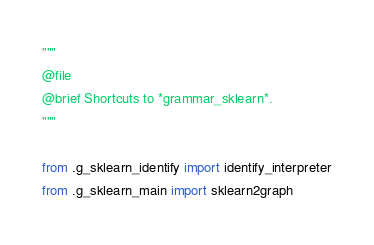<code> <loc_0><loc_0><loc_500><loc_500><_Python_>"""
@file
@brief Shortcuts to *grammar_sklearn*.
"""

from .g_sklearn_identify import identify_interpreter
from .g_sklearn_main import sklearn2graph
</code> 